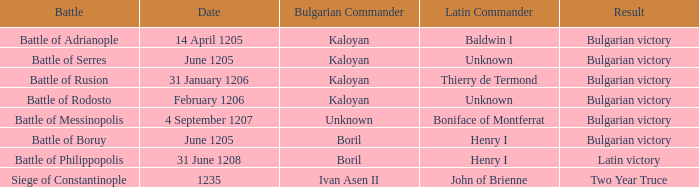At the battle of boruy, when did henry i hold the position of latin commander? June 1205. 